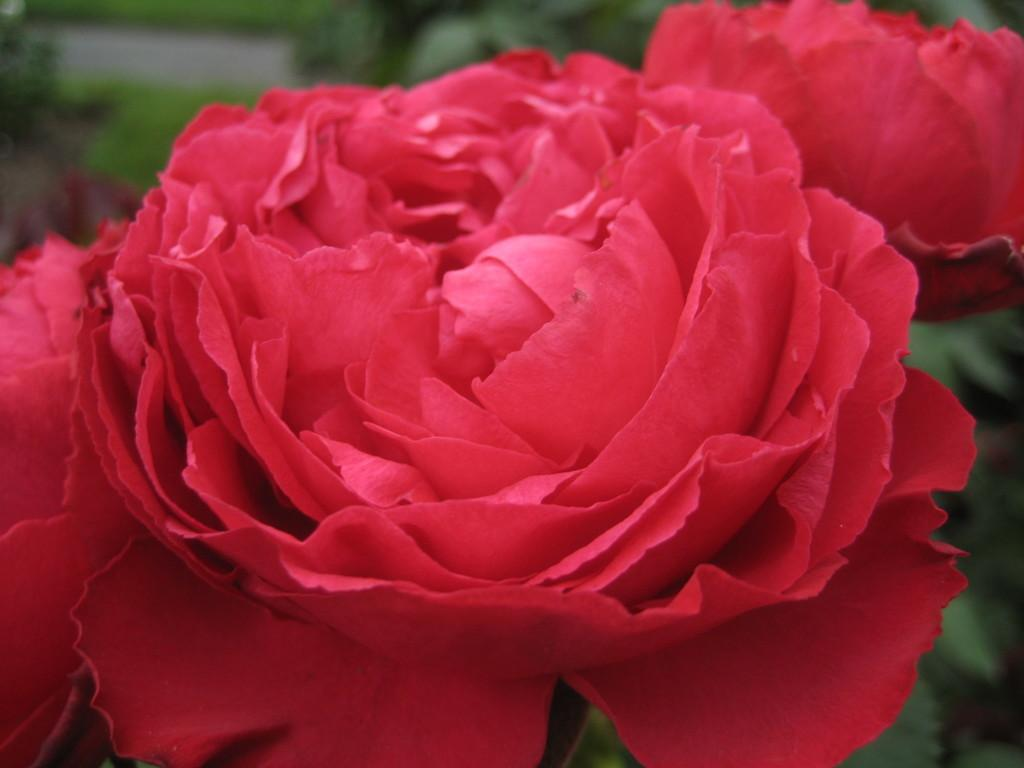How many rose flowers can be seen in the image? There are two rose flowers in the image. What else can be seen in the image besides the rose flowers? There are many plants visible in the image. What type of pleasure can be seen in the image? There is no pleasure visible in the image; it features two rose flowers and many plants. What is the source of shame in the image? There is no shame present in the image; it is a simple depiction of flowers and plants. 